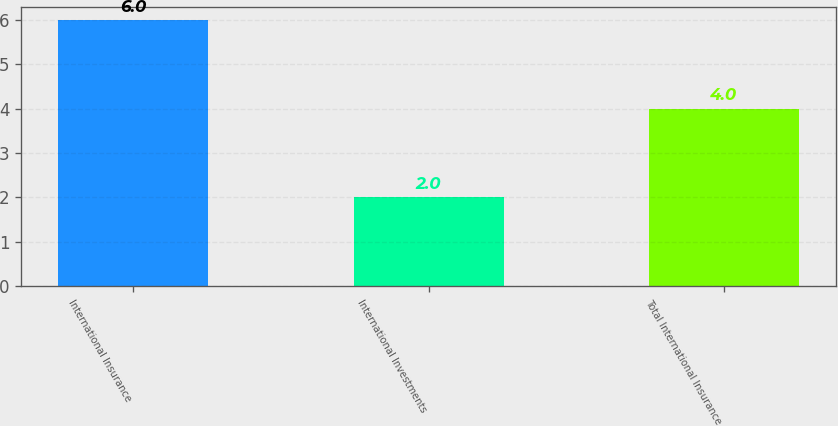Convert chart. <chart><loc_0><loc_0><loc_500><loc_500><bar_chart><fcel>International Insurance<fcel>International Investments<fcel>Total International Insurance<nl><fcel>6<fcel>2<fcel>4<nl></chart> 